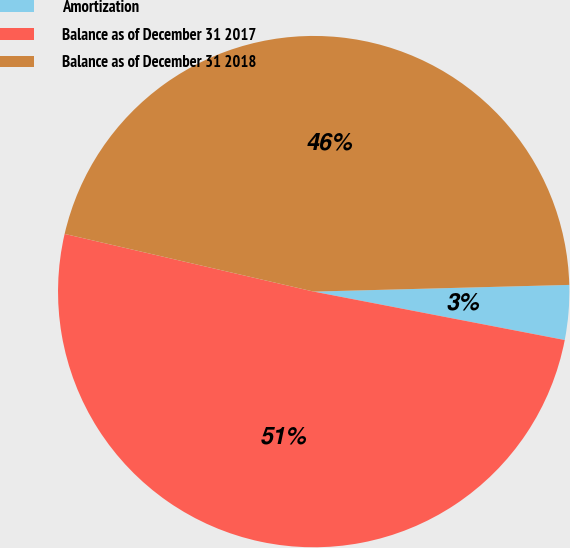Convert chart. <chart><loc_0><loc_0><loc_500><loc_500><pie_chart><fcel>Amortization<fcel>Balance as of December 31 2017<fcel>Balance as of December 31 2018<nl><fcel>3.45%<fcel>50.59%<fcel>45.96%<nl></chart> 